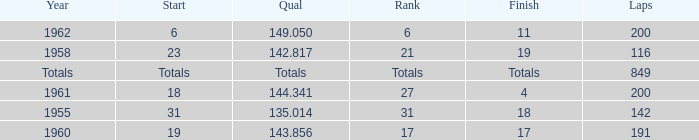What is the year with 116 laps? 1958.0. 